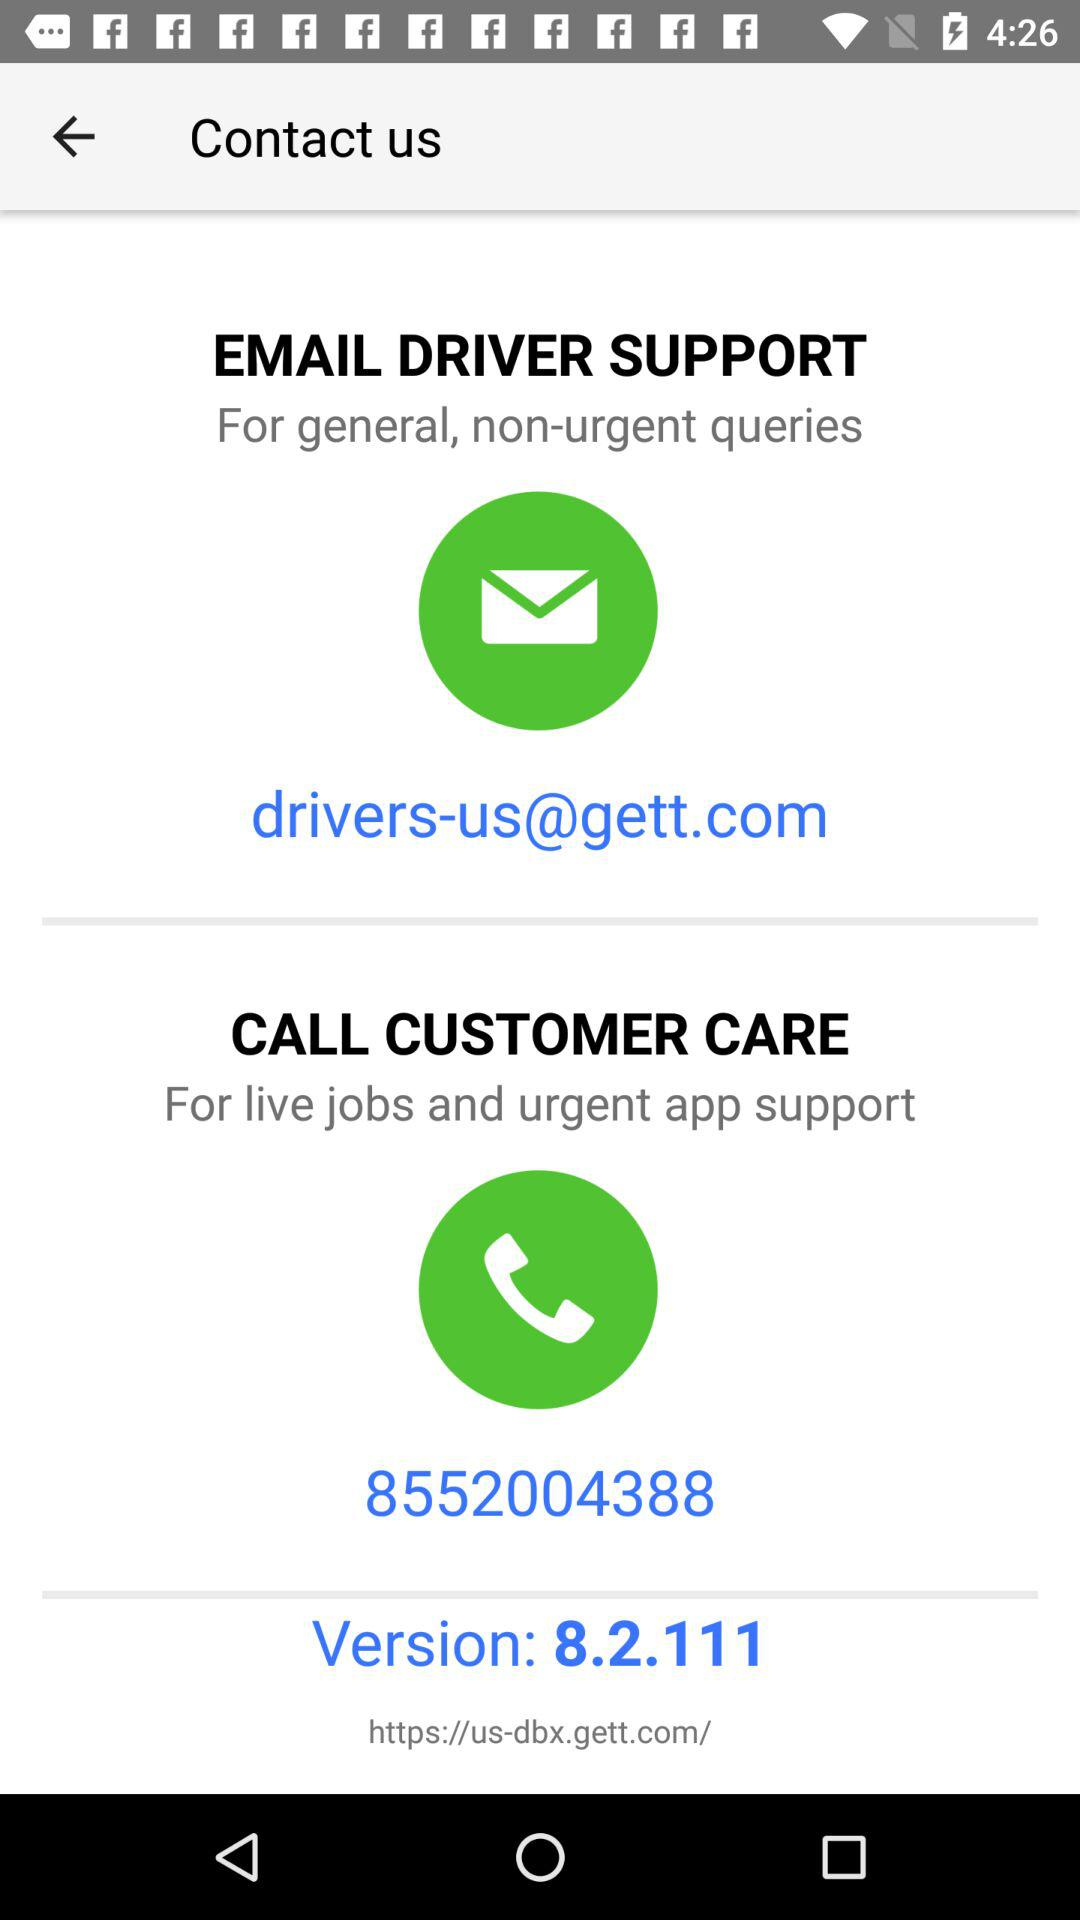How many contact us options are available?
Answer the question using a single word or phrase. 2 